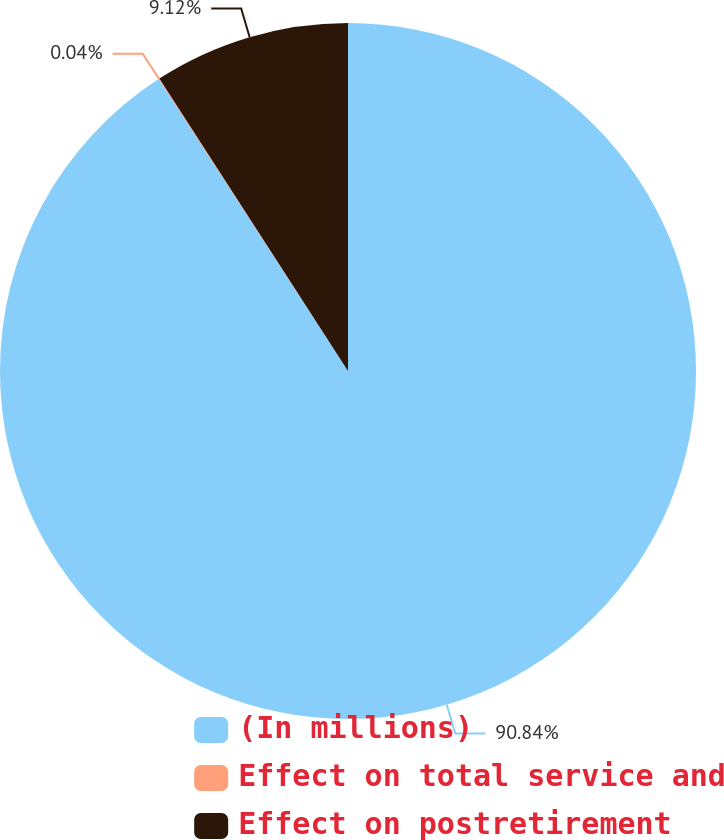Convert chart. <chart><loc_0><loc_0><loc_500><loc_500><pie_chart><fcel>(In millions)<fcel>Effect on total service and<fcel>Effect on postretirement<nl><fcel>90.84%<fcel>0.04%<fcel>9.12%<nl></chart> 